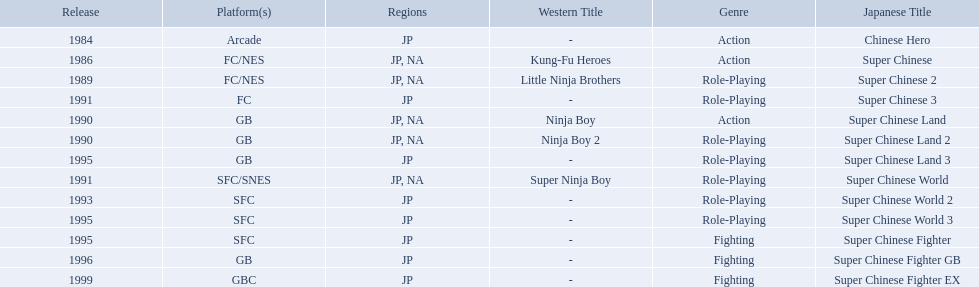Super ninja world was released in what countries? JP, NA. What was the original name for this title? Super Chinese World. 